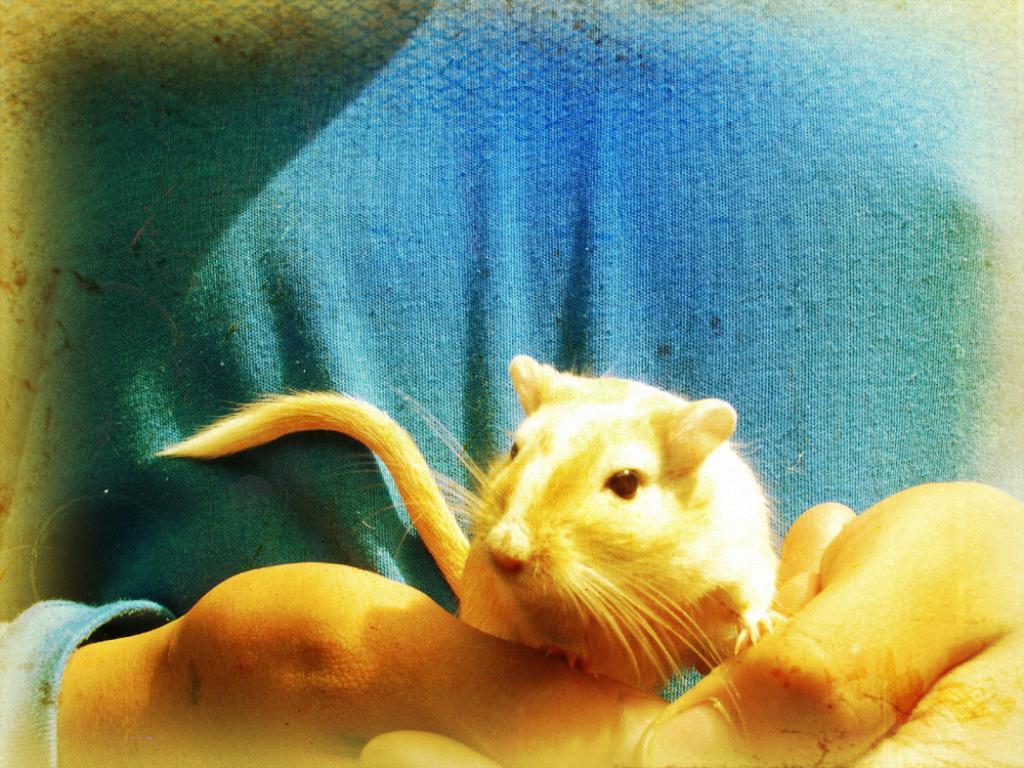Can you describe this image briefly? In this image we can see a person holding a mouse. 